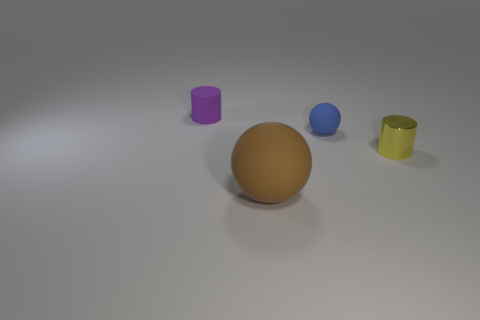Add 3 big purple balls. How many objects exist? 7 Add 4 big brown rubber spheres. How many big brown rubber spheres exist? 5 Subtract 1 purple cylinders. How many objects are left? 3 Subtract all small gray metal things. Subtract all brown rubber objects. How many objects are left? 3 Add 3 big matte objects. How many big matte objects are left? 4 